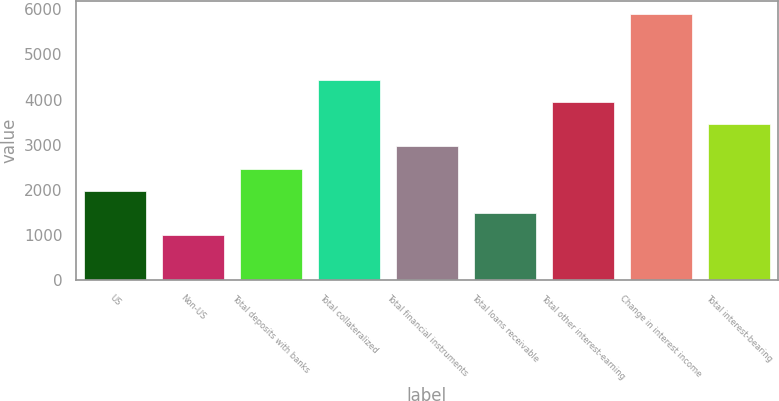<chart> <loc_0><loc_0><loc_500><loc_500><bar_chart><fcel>US<fcel>Non-US<fcel>Total deposits with banks<fcel>Total collateralized<fcel>Total financial instruments<fcel>Total loans receivable<fcel>Total other interest-earning<fcel>Change in interest income<fcel>Total interest-bearing<nl><fcel>1987<fcel>1012<fcel>2474.5<fcel>4424.5<fcel>2962<fcel>1499.5<fcel>3937<fcel>5887<fcel>3449.5<nl></chart> 